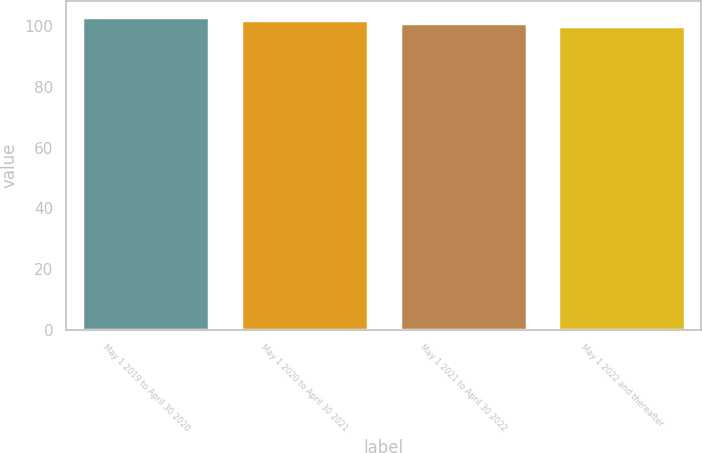Convert chart to OTSL. <chart><loc_0><loc_0><loc_500><loc_500><bar_chart><fcel>May 1 2019 to April 30 2020<fcel>May 1 2020 to April 30 2021<fcel>May 1 2021 to April 30 2022<fcel>May 1 2022 and thereafter<nl><fcel>103.12<fcel>102.08<fcel>101.04<fcel>100<nl></chart> 